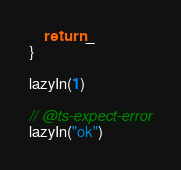<code> <loc_0><loc_0><loc_500><loc_500><_TypeScript_>    return _
}

lazyIn(1)

// @ts-expect-error
lazyIn("ok")</code> 